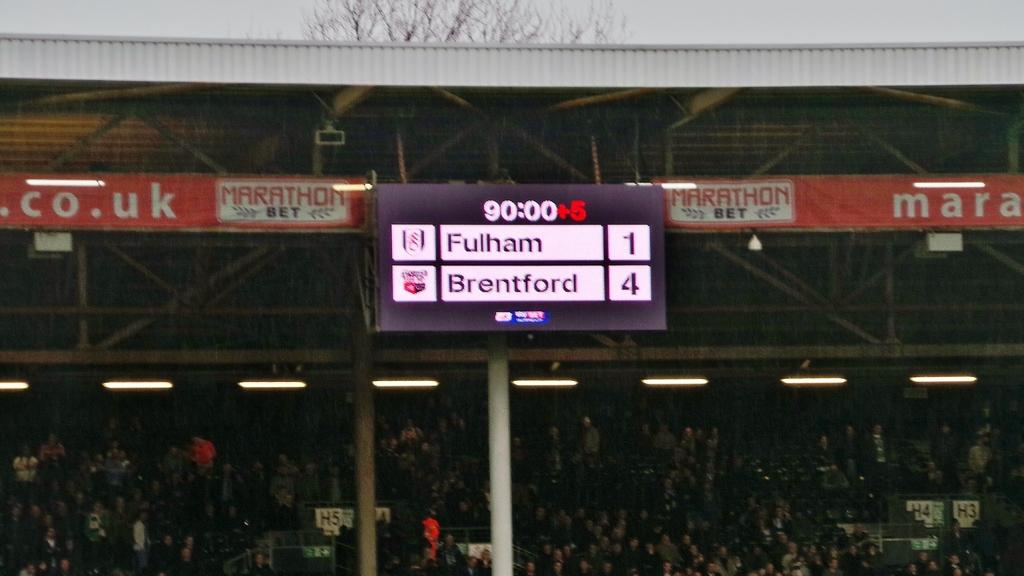<image>
Give a short and clear explanation of the subsequent image. A scoreboard at a sporting event showing Fulham with 1 point and Brentford with 4 points. 